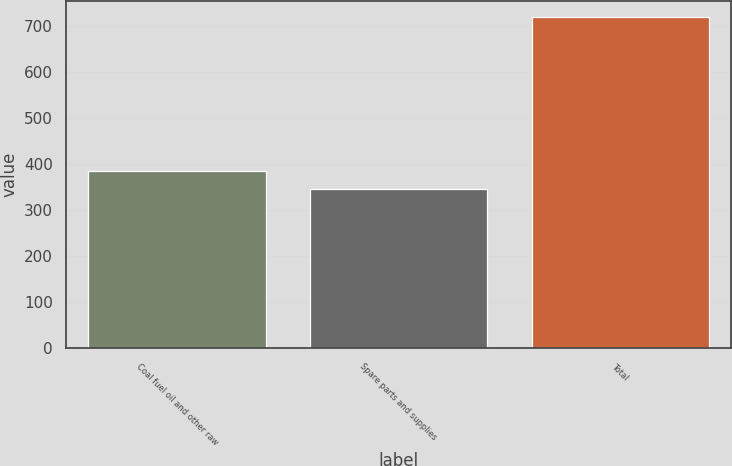Convert chart. <chart><loc_0><loc_0><loc_500><loc_500><bar_chart><fcel>Coal fuel oil and other raw<fcel>Spare parts and supplies<fcel>Total<nl><fcel>384.2<fcel>347<fcel>719<nl></chart> 